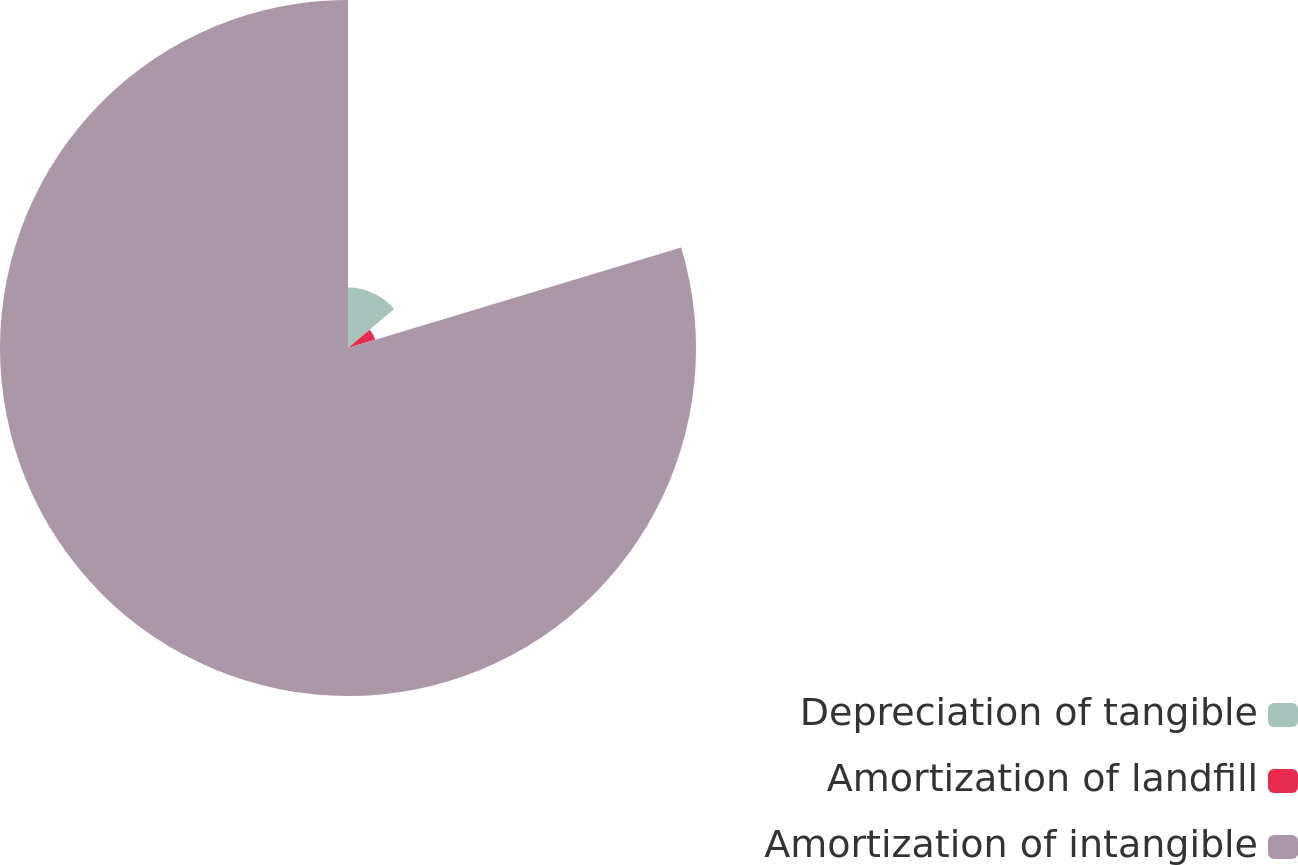Convert chart. <chart><loc_0><loc_0><loc_500><loc_500><pie_chart><fcel>Depreciation of tangible<fcel>Amortization of landfill<fcel>Amortization of intangible<nl><fcel>13.83%<fcel>6.51%<fcel>79.66%<nl></chart> 